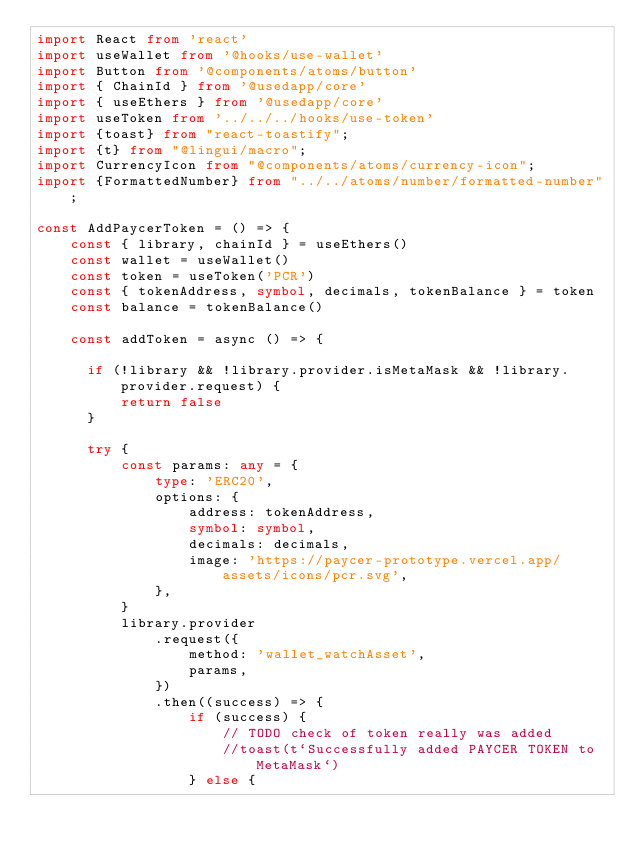Convert code to text. <code><loc_0><loc_0><loc_500><loc_500><_TypeScript_>import React from 'react'
import useWallet from '@hooks/use-wallet'
import Button from '@components/atoms/button'
import { ChainId } from '@usedapp/core'
import { useEthers } from '@usedapp/core'
import useToken from '../../../hooks/use-token'
import {toast} from "react-toastify";
import {t} from "@lingui/macro";
import CurrencyIcon from "@components/atoms/currency-icon";
import {FormattedNumber} from "../../atoms/number/formatted-number";

const AddPaycerToken = () => {
    const { library, chainId } = useEthers()
    const wallet = useWallet()
    const token = useToken('PCR')
    const { tokenAddress, symbol, decimals, tokenBalance } = token
    const balance = tokenBalance()

    const addToken = async () => {

      if (!library && !library.provider.isMetaMask && !library.provider.request) {
          return false
      }

      try {
          const params: any = {
              type: 'ERC20',
              options: {
                  address: tokenAddress,
                  symbol: symbol,
                  decimals: decimals,
                  image: 'https://paycer-prototype.vercel.app/assets/icons/pcr.svg',
              },
          }
          library.provider
              .request({
                  method: 'wallet_watchAsset',
                  params,
              })
              .then((success) => {
                  if (success) {
                      // TODO check of token really was added
                      //toast(t`Successfully added PAYCER TOKEN to MetaMask`)
                  } else {</code> 